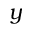<formula> <loc_0><loc_0><loc_500><loc_500>y</formula> 